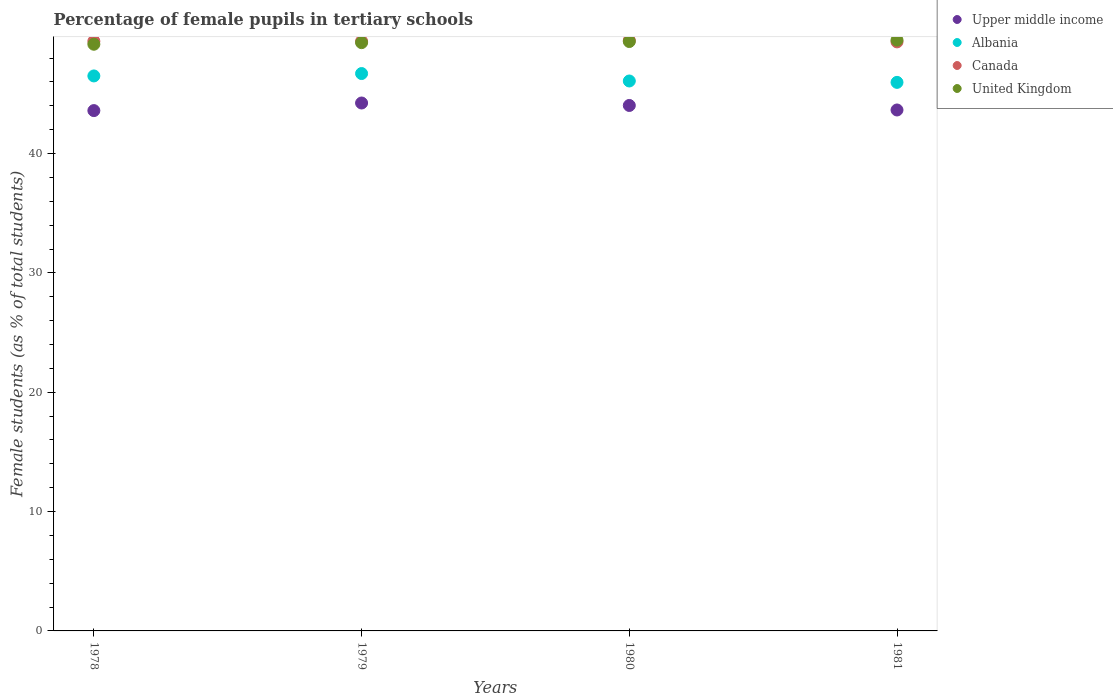What is the percentage of female pupils in tertiary schools in United Kingdom in 1981?
Give a very brief answer. 49.51. Across all years, what is the maximum percentage of female pupils in tertiary schools in United Kingdom?
Give a very brief answer. 49.51. Across all years, what is the minimum percentage of female pupils in tertiary schools in Canada?
Offer a very short reply. 49.36. In which year was the percentage of female pupils in tertiary schools in Upper middle income maximum?
Offer a very short reply. 1979. In which year was the percentage of female pupils in tertiary schools in Canada minimum?
Give a very brief answer. 1981. What is the total percentage of female pupils in tertiary schools in Upper middle income in the graph?
Keep it short and to the point. 175.52. What is the difference between the percentage of female pupils in tertiary schools in United Kingdom in 1978 and that in 1981?
Keep it short and to the point. -0.35. What is the difference between the percentage of female pupils in tertiary schools in Upper middle income in 1979 and the percentage of female pupils in tertiary schools in Canada in 1980?
Offer a very short reply. -5.25. What is the average percentage of female pupils in tertiary schools in Albania per year?
Keep it short and to the point. 46.31. In the year 1980, what is the difference between the percentage of female pupils in tertiary schools in Upper middle income and percentage of female pupils in tertiary schools in Canada?
Make the answer very short. -5.45. In how many years, is the percentage of female pupils in tertiary schools in Albania greater than 2 %?
Provide a short and direct response. 4. What is the ratio of the percentage of female pupils in tertiary schools in Albania in 1978 to that in 1981?
Your answer should be very brief. 1.01. Is the percentage of female pupils in tertiary schools in Albania in 1979 less than that in 1980?
Keep it short and to the point. No. What is the difference between the highest and the second highest percentage of female pupils in tertiary schools in Upper middle income?
Give a very brief answer. 0.21. What is the difference between the highest and the lowest percentage of female pupils in tertiary schools in Canada?
Provide a short and direct response. 0.13. In how many years, is the percentage of female pupils in tertiary schools in Upper middle income greater than the average percentage of female pupils in tertiary schools in Upper middle income taken over all years?
Ensure brevity in your answer.  2. Is it the case that in every year, the sum of the percentage of female pupils in tertiary schools in United Kingdom and percentage of female pupils in tertiary schools in Upper middle income  is greater than the sum of percentage of female pupils in tertiary schools in Canada and percentage of female pupils in tertiary schools in Albania?
Offer a terse response. No. Does the percentage of female pupils in tertiary schools in Upper middle income monotonically increase over the years?
Offer a terse response. No. Is the percentage of female pupils in tertiary schools in Canada strictly greater than the percentage of female pupils in tertiary schools in United Kingdom over the years?
Your answer should be compact. No. How many dotlines are there?
Your answer should be compact. 4. How many years are there in the graph?
Give a very brief answer. 4. What is the difference between two consecutive major ticks on the Y-axis?
Give a very brief answer. 10. Does the graph contain any zero values?
Your answer should be very brief. No. Does the graph contain grids?
Your response must be concise. No. Where does the legend appear in the graph?
Provide a succinct answer. Top right. How are the legend labels stacked?
Ensure brevity in your answer.  Vertical. What is the title of the graph?
Offer a very short reply. Percentage of female pupils in tertiary schools. Does "Djibouti" appear as one of the legend labels in the graph?
Provide a succinct answer. No. What is the label or title of the Y-axis?
Give a very brief answer. Female students (as % of total students). What is the Female students (as % of total students) in Upper middle income in 1978?
Ensure brevity in your answer.  43.6. What is the Female students (as % of total students) in Albania in 1978?
Your answer should be very brief. 46.51. What is the Female students (as % of total students) of Canada in 1978?
Provide a succinct answer. 49.41. What is the Female students (as % of total students) in United Kingdom in 1978?
Ensure brevity in your answer.  49.16. What is the Female students (as % of total students) of Upper middle income in 1979?
Ensure brevity in your answer.  44.24. What is the Female students (as % of total students) of Albania in 1979?
Make the answer very short. 46.71. What is the Female students (as % of total students) in Canada in 1979?
Give a very brief answer. 49.41. What is the Female students (as % of total students) of United Kingdom in 1979?
Ensure brevity in your answer.  49.29. What is the Female students (as % of total students) in Upper middle income in 1980?
Ensure brevity in your answer.  44.03. What is the Female students (as % of total students) of Albania in 1980?
Give a very brief answer. 46.08. What is the Female students (as % of total students) of Canada in 1980?
Your response must be concise. 49.48. What is the Female students (as % of total students) of United Kingdom in 1980?
Keep it short and to the point. 49.39. What is the Female students (as % of total students) of Upper middle income in 1981?
Your response must be concise. 43.65. What is the Female students (as % of total students) in Albania in 1981?
Ensure brevity in your answer.  45.97. What is the Female students (as % of total students) of Canada in 1981?
Provide a succinct answer. 49.36. What is the Female students (as % of total students) of United Kingdom in 1981?
Keep it short and to the point. 49.51. Across all years, what is the maximum Female students (as % of total students) of Upper middle income?
Offer a very short reply. 44.24. Across all years, what is the maximum Female students (as % of total students) in Albania?
Make the answer very short. 46.71. Across all years, what is the maximum Female students (as % of total students) of Canada?
Your answer should be very brief. 49.48. Across all years, what is the maximum Female students (as % of total students) of United Kingdom?
Offer a terse response. 49.51. Across all years, what is the minimum Female students (as % of total students) in Upper middle income?
Ensure brevity in your answer.  43.6. Across all years, what is the minimum Female students (as % of total students) in Albania?
Provide a short and direct response. 45.97. Across all years, what is the minimum Female students (as % of total students) of Canada?
Offer a terse response. 49.36. Across all years, what is the minimum Female students (as % of total students) of United Kingdom?
Provide a succinct answer. 49.16. What is the total Female students (as % of total students) in Upper middle income in the graph?
Your answer should be compact. 175.52. What is the total Female students (as % of total students) in Albania in the graph?
Your response must be concise. 185.26. What is the total Female students (as % of total students) in Canada in the graph?
Keep it short and to the point. 197.67. What is the total Female students (as % of total students) of United Kingdom in the graph?
Make the answer very short. 197.35. What is the difference between the Female students (as % of total students) of Upper middle income in 1978 and that in 1979?
Offer a very short reply. -0.64. What is the difference between the Female students (as % of total students) in Albania in 1978 and that in 1979?
Make the answer very short. -0.2. What is the difference between the Female students (as % of total students) of Canada in 1978 and that in 1979?
Make the answer very short. 0.01. What is the difference between the Female students (as % of total students) of United Kingdom in 1978 and that in 1979?
Provide a succinct answer. -0.13. What is the difference between the Female students (as % of total students) of Upper middle income in 1978 and that in 1980?
Offer a very short reply. -0.43. What is the difference between the Female students (as % of total students) of Albania in 1978 and that in 1980?
Your answer should be compact. 0.42. What is the difference between the Female students (as % of total students) in Canada in 1978 and that in 1980?
Keep it short and to the point. -0.07. What is the difference between the Female students (as % of total students) in United Kingdom in 1978 and that in 1980?
Ensure brevity in your answer.  -0.23. What is the difference between the Female students (as % of total students) of Upper middle income in 1978 and that in 1981?
Offer a terse response. -0.05. What is the difference between the Female students (as % of total students) of Albania in 1978 and that in 1981?
Ensure brevity in your answer.  0.54. What is the difference between the Female students (as % of total students) in Canada in 1978 and that in 1981?
Offer a terse response. 0.06. What is the difference between the Female students (as % of total students) of United Kingdom in 1978 and that in 1981?
Keep it short and to the point. -0.35. What is the difference between the Female students (as % of total students) in Upper middle income in 1979 and that in 1980?
Offer a very short reply. 0.21. What is the difference between the Female students (as % of total students) in Albania in 1979 and that in 1980?
Make the answer very short. 0.62. What is the difference between the Female students (as % of total students) in Canada in 1979 and that in 1980?
Offer a very short reply. -0.08. What is the difference between the Female students (as % of total students) in United Kingdom in 1979 and that in 1980?
Keep it short and to the point. -0.09. What is the difference between the Female students (as % of total students) of Upper middle income in 1979 and that in 1981?
Your answer should be very brief. 0.59. What is the difference between the Female students (as % of total students) in Albania in 1979 and that in 1981?
Ensure brevity in your answer.  0.74. What is the difference between the Female students (as % of total students) in Canada in 1979 and that in 1981?
Offer a very short reply. 0.05. What is the difference between the Female students (as % of total students) of United Kingdom in 1979 and that in 1981?
Offer a very short reply. -0.21. What is the difference between the Female students (as % of total students) in Upper middle income in 1980 and that in 1981?
Keep it short and to the point. 0.38. What is the difference between the Female students (as % of total students) in Albania in 1980 and that in 1981?
Give a very brief answer. 0.12. What is the difference between the Female students (as % of total students) in Canada in 1980 and that in 1981?
Give a very brief answer. 0.13. What is the difference between the Female students (as % of total students) in United Kingdom in 1980 and that in 1981?
Offer a very short reply. -0.12. What is the difference between the Female students (as % of total students) in Upper middle income in 1978 and the Female students (as % of total students) in Albania in 1979?
Your answer should be compact. -3.1. What is the difference between the Female students (as % of total students) of Upper middle income in 1978 and the Female students (as % of total students) of Canada in 1979?
Ensure brevity in your answer.  -5.81. What is the difference between the Female students (as % of total students) in Upper middle income in 1978 and the Female students (as % of total students) in United Kingdom in 1979?
Your answer should be compact. -5.69. What is the difference between the Female students (as % of total students) in Albania in 1978 and the Female students (as % of total students) in Canada in 1979?
Ensure brevity in your answer.  -2.9. What is the difference between the Female students (as % of total students) in Albania in 1978 and the Female students (as % of total students) in United Kingdom in 1979?
Provide a succinct answer. -2.79. What is the difference between the Female students (as % of total students) of Canada in 1978 and the Female students (as % of total students) of United Kingdom in 1979?
Make the answer very short. 0.12. What is the difference between the Female students (as % of total students) in Upper middle income in 1978 and the Female students (as % of total students) in Albania in 1980?
Your answer should be very brief. -2.48. What is the difference between the Female students (as % of total students) in Upper middle income in 1978 and the Female students (as % of total students) in Canada in 1980?
Give a very brief answer. -5.88. What is the difference between the Female students (as % of total students) of Upper middle income in 1978 and the Female students (as % of total students) of United Kingdom in 1980?
Your response must be concise. -5.79. What is the difference between the Female students (as % of total students) in Albania in 1978 and the Female students (as % of total students) in Canada in 1980?
Provide a short and direct response. -2.98. What is the difference between the Female students (as % of total students) in Albania in 1978 and the Female students (as % of total students) in United Kingdom in 1980?
Give a very brief answer. -2.88. What is the difference between the Female students (as % of total students) of Canada in 1978 and the Female students (as % of total students) of United Kingdom in 1980?
Offer a very short reply. 0.03. What is the difference between the Female students (as % of total students) of Upper middle income in 1978 and the Female students (as % of total students) of Albania in 1981?
Make the answer very short. -2.37. What is the difference between the Female students (as % of total students) of Upper middle income in 1978 and the Female students (as % of total students) of Canada in 1981?
Your answer should be very brief. -5.76. What is the difference between the Female students (as % of total students) of Upper middle income in 1978 and the Female students (as % of total students) of United Kingdom in 1981?
Provide a succinct answer. -5.91. What is the difference between the Female students (as % of total students) in Albania in 1978 and the Female students (as % of total students) in Canada in 1981?
Provide a succinct answer. -2.85. What is the difference between the Female students (as % of total students) in Albania in 1978 and the Female students (as % of total students) in United Kingdom in 1981?
Provide a succinct answer. -3. What is the difference between the Female students (as % of total students) in Canada in 1978 and the Female students (as % of total students) in United Kingdom in 1981?
Your answer should be compact. -0.09. What is the difference between the Female students (as % of total students) in Upper middle income in 1979 and the Female students (as % of total students) in Albania in 1980?
Ensure brevity in your answer.  -1.84. What is the difference between the Female students (as % of total students) in Upper middle income in 1979 and the Female students (as % of total students) in Canada in 1980?
Give a very brief answer. -5.25. What is the difference between the Female students (as % of total students) in Upper middle income in 1979 and the Female students (as % of total students) in United Kingdom in 1980?
Offer a terse response. -5.15. What is the difference between the Female students (as % of total students) of Albania in 1979 and the Female students (as % of total students) of Canada in 1980?
Your answer should be very brief. -2.78. What is the difference between the Female students (as % of total students) in Albania in 1979 and the Female students (as % of total students) in United Kingdom in 1980?
Your answer should be very brief. -2.68. What is the difference between the Female students (as % of total students) in Canada in 1979 and the Female students (as % of total students) in United Kingdom in 1980?
Your answer should be very brief. 0.02. What is the difference between the Female students (as % of total students) of Upper middle income in 1979 and the Female students (as % of total students) of Albania in 1981?
Provide a succinct answer. -1.73. What is the difference between the Female students (as % of total students) of Upper middle income in 1979 and the Female students (as % of total students) of Canada in 1981?
Give a very brief answer. -5.12. What is the difference between the Female students (as % of total students) of Upper middle income in 1979 and the Female students (as % of total students) of United Kingdom in 1981?
Your response must be concise. -5.27. What is the difference between the Female students (as % of total students) of Albania in 1979 and the Female students (as % of total students) of Canada in 1981?
Your answer should be very brief. -2.65. What is the difference between the Female students (as % of total students) in Albania in 1979 and the Female students (as % of total students) in United Kingdom in 1981?
Make the answer very short. -2.8. What is the difference between the Female students (as % of total students) of Canada in 1979 and the Female students (as % of total students) of United Kingdom in 1981?
Your response must be concise. -0.1. What is the difference between the Female students (as % of total students) in Upper middle income in 1980 and the Female students (as % of total students) in Albania in 1981?
Your answer should be very brief. -1.93. What is the difference between the Female students (as % of total students) in Upper middle income in 1980 and the Female students (as % of total students) in Canada in 1981?
Your answer should be very brief. -5.33. What is the difference between the Female students (as % of total students) in Upper middle income in 1980 and the Female students (as % of total students) in United Kingdom in 1981?
Your answer should be very brief. -5.48. What is the difference between the Female students (as % of total students) in Albania in 1980 and the Female students (as % of total students) in Canada in 1981?
Provide a succinct answer. -3.28. What is the difference between the Female students (as % of total students) in Albania in 1980 and the Female students (as % of total students) in United Kingdom in 1981?
Your answer should be very brief. -3.43. What is the difference between the Female students (as % of total students) of Canada in 1980 and the Female students (as % of total students) of United Kingdom in 1981?
Provide a short and direct response. -0.02. What is the average Female students (as % of total students) of Upper middle income per year?
Keep it short and to the point. 43.88. What is the average Female students (as % of total students) in Albania per year?
Your answer should be compact. 46.31. What is the average Female students (as % of total students) in Canada per year?
Your response must be concise. 49.42. What is the average Female students (as % of total students) in United Kingdom per year?
Offer a terse response. 49.34. In the year 1978, what is the difference between the Female students (as % of total students) in Upper middle income and Female students (as % of total students) in Albania?
Your answer should be compact. -2.9. In the year 1978, what is the difference between the Female students (as % of total students) in Upper middle income and Female students (as % of total students) in Canada?
Your answer should be compact. -5.81. In the year 1978, what is the difference between the Female students (as % of total students) in Upper middle income and Female students (as % of total students) in United Kingdom?
Your answer should be very brief. -5.56. In the year 1978, what is the difference between the Female students (as % of total students) in Albania and Female students (as % of total students) in Canada?
Your response must be concise. -2.91. In the year 1978, what is the difference between the Female students (as % of total students) in Albania and Female students (as % of total students) in United Kingdom?
Make the answer very short. -2.66. In the year 1978, what is the difference between the Female students (as % of total students) of Canada and Female students (as % of total students) of United Kingdom?
Provide a succinct answer. 0.25. In the year 1979, what is the difference between the Female students (as % of total students) in Upper middle income and Female students (as % of total students) in Albania?
Make the answer very short. -2.47. In the year 1979, what is the difference between the Female students (as % of total students) of Upper middle income and Female students (as % of total students) of Canada?
Your answer should be compact. -5.17. In the year 1979, what is the difference between the Female students (as % of total students) of Upper middle income and Female students (as % of total students) of United Kingdom?
Your response must be concise. -5.06. In the year 1979, what is the difference between the Female students (as % of total students) in Albania and Female students (as % of total students) in Canada?
Your response must be concise. -2.7. In the year 1979, what is the difference between the Female students (as % of total students) in Albania and Female students (as % of total students) in United Kingdom?
Provide a succinct answer. -2.59. In the year 1979, what is the difference between the Female students (as % of total students) in Canada and Female students (as % of total students) in United Kingdom?
Ensure brevity in your answer.  0.11. In the year 1980, what is the difference between the Female students (as % of total students) of Upper middle income and Female students (as % of total students) of Albania?
Your response must be concise. -2.05. In the year 1980, what is the difference between the Female students (as % of total students) in Upper middle income and Female students (as % of total students) in Canada?
Give a very brief answer. -5.45. In the year 1980, what is the difference between the Female students (as % of total students) of Upper middle income and Female students (as % of total students) of United Kingdom?
Your answer should be compact. -5.36. In the year 1980, what is the difference between the Female students (as % of total students) in Albania and Female students (as % of total students) in Canada?
Your answer should be very brief. -3.4. In the year 1980, what is the difference between the Female students (as % of total students) of Albania and Female students (as % of total students) of United Kingdom?
Your answer should be compact. -3.31. In the year 1980, what is the difference between the Female students (as % of total students) of Canada and Female students (as % of total students) of United Kingdom?
Offer a very short reply. 0.1. In the year 1981, what is the difference between the Female students (as % of total students) in Upper middle income and Female students (as % of total students) in Albania?
Make the answer very short. -2.31. In the year 1981, what is the difference between the Female students (as % of total students) of Upper middle income and Female students (as % of total students) of Canada?
Provide a short and direct response. -5.71. In the year 1981, what is the difference between the Female students (as % of total students) of Upper middle income and Female students (as % of total students) of United Kingdom?
Offer a terse response. -5.86. In the year 1981, what is the difference between the Female students (as % of total students) of Albania and Female students (as % of total students) of Canada?
Your answer should be compact. -3.39. In the year 1981, what is the difference between the Female students (as % of total students) of Albania and Female students (as % of total students) of United Kingdom?
Provide a succinct answer. -3.54. In the year 1981, what is the difference between the Female students (as % of total students) in Canada and Female students (as % of total students) in United Kingdom?
Your response must be concise. -0.15. What is the ratio of the Female students (as % of total students) of Upper middle income in 1978 to that in 1979?
Offer a very short reply. 0.99. What is the ratio of the Female students (as % of total students) in Albania in 1978 to that in 1979?
Your response must be concise. 1. What is the ratio of the Female students (as % of total students) in Canada in 1978 to that in 1979?
Keep it short and to the point. 1. What is the ratio of the Female students (as % of total students) in Upper middle income in 1978 to that in 1980?
Offer a terse response. 0.99. What is the ratio of the Female students (as % of total students) of Albania in 1978 to that in 1980?
Offer a very short reply. 1.01. What is the ratio of the Female students (as % of total students) in Canada in 1978 to that in 1980?
Provide a succinct answer. 1. What is the ratio of the Female students (as % of total students) in United Kingdom in 1978 to that in 1980?
Your answer should be compact. 1. What is the ratio of the Female students (as % of total students) of Albania in 1978 to that in 1981?
Offer a terse response. 1.01. What is the ratio of the Female students (as % of total students) in Upper middle income in 1979 to that in 1980?
Give a very brief answer. 1. What is the ratio of the Female students (as % of total students) in Albania in 1979 to that in 1980?
Make the answer very short. 1.01. What is the ratio of the Female students (as % of total students) of Upper middle income in 1979 to that in 1981?
Your answer should be very brief. 1.01. What is the ratio of the Female students (as % of total students) of Albania in 1979 to that in 1981?
Offer a terse response. 1.02. What is the ratio of the Female students (as % of total students) of United Kingdom in 1979 to that in 1981?
Offer a terse response. 1. What is the ratio of the Female students (as % of total students) in Upper middle income in 1980 to that in 1981?
Provide a short and direct response. 1.01. What is the ratio of the Female students (as % of total students) of Canada in 1980 to that in 1981?
Ensure brevity in your answer.  1. What is the difference between the highest and the second highest Female students (as % of total students) in Upper middle income?
Provide a short and direct response. 0.21. What is the difference between the highest and the second highest Female students (as % of total students) in Albania?
Make the answer very short. 0.2. What is the difference between the highest and the second highest Female students (as % of total students) of Canada?
Make the answer very short. 0.07. What is the difference between the highest and the second highest Female students (as % of total students) in United Kingdom?
Keep it short and to the point. 0.12. What is the difference between the highest and the lowest Female students (as % of total students) of Upper middle income?
Provide a succinct answer. 0.64. What is the difference between the highest and the lowest Female students (as % of total students) of Albania?
Your answer should be very brief. 0.74. What is the difference between the highest and the lowest Female students (as % of total students) of Canada?
Your answer should be very brief. 0.13. What is the difference between the highest and the lowest Female students (as % of total students) in United Kingdom?
Offer a terse response. 0.35. 